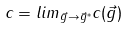Convert formula to latex. <formula><loc_0><loc_0><loc_500><loc_500>c = l i m _ { \vec { g } \rightarrow \vec { g } ^ { * } } c ( \vec { g } )</formula> 